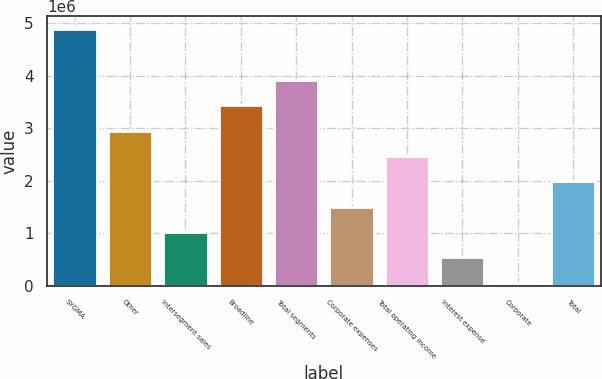Convert chart. <chart><loc_0><loc_0><loc_500><loc_500><bar_chart><fcel>SYGMA<fcel>Other<fcel>Intersegment sales<fcel>Broadline<fcel>Total segments<fcel>Corporate expenses<fcel>Total operating income<fcel>Interest expense<fcel>Corporate<fcel>Total<nl><fcel>4.89128e+06<fcel>2.95722e+06<fcel>1.02316e+06<fcel>3.44073e+06<fcel>3.92425e+06<fcel>1.50667e+06<fcel>2.4737e+06<fcel>539641<fcel>56126<fcel>1.99019e+06<nl></chart> 